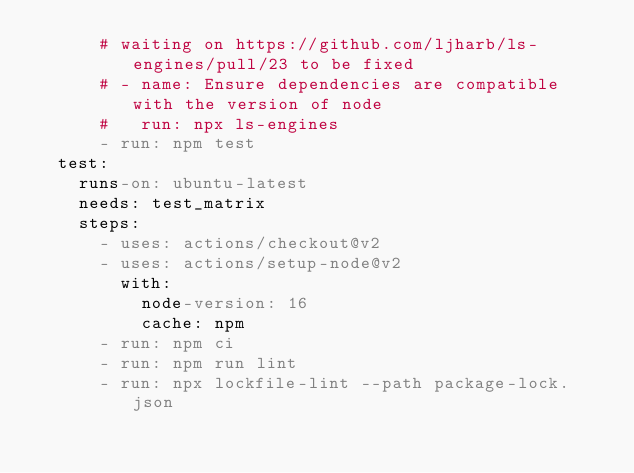<code> <loc_0><loc_0><loc_500><loc_500><_YAML_>      # waiting on https://github.com/ljharb/ls-engines/pull/23 to be fixed
      # - name: Ensure dependencies are compatible with the version of node
      #   run: npx ls-engines
      - run: npm test
  test:
    runs-on: ubuntu-latest
    needs: test_matrix
    steps:
      - uses: actions/checkout@v2
      - uses: actions/setup-node@v2
        with:
          node-version: 16
          cache: npm
      - run: npm ci
      - run: npm run lint
      - run: npx lockfile-lint --path package-lock.json
</code> 